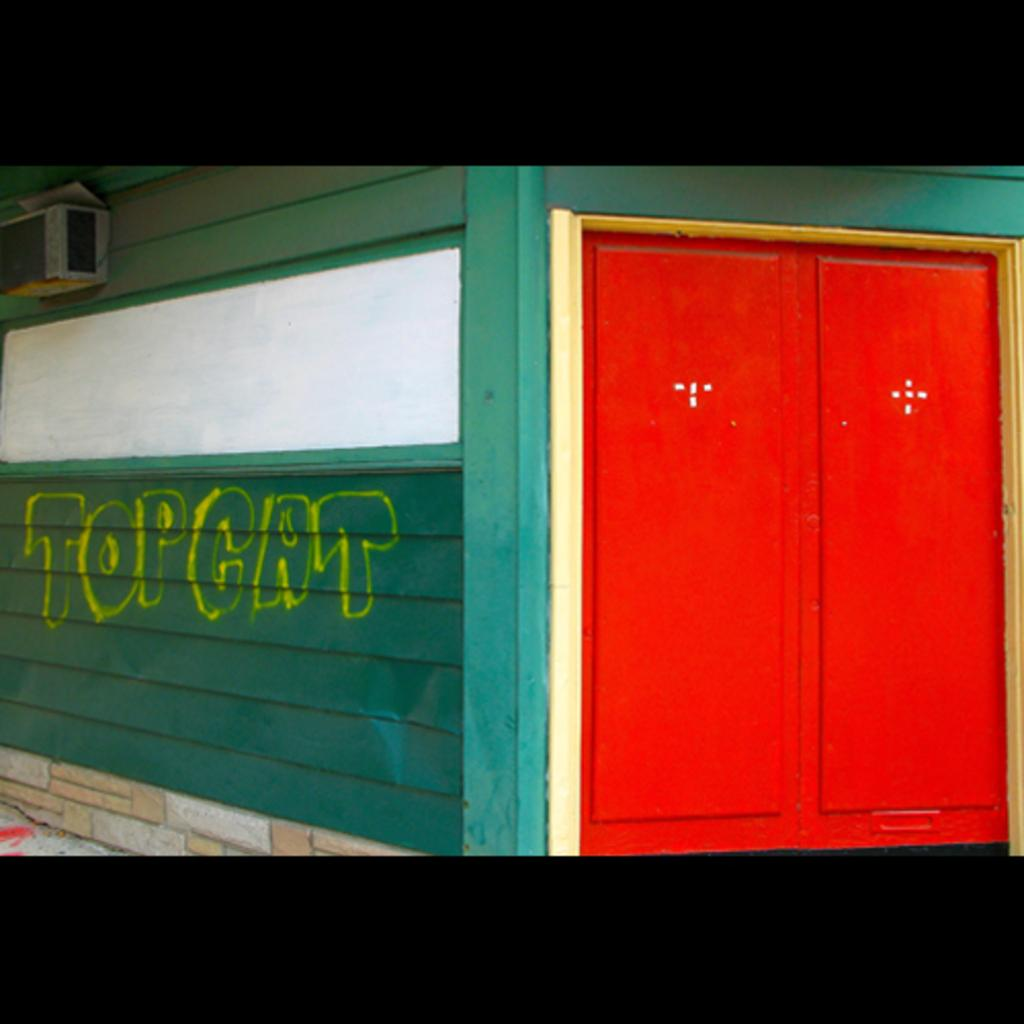What type of structure can be seen in the image? There is a wall in the image. Is there any entrance visible in the image? Yes, there is a door in the image. What type of oil can be seen dripping from the wall in the image? There is no oil present in the image; it only features a wall and a door. How many feet are visible in the image? There are no feet visible in the image. 